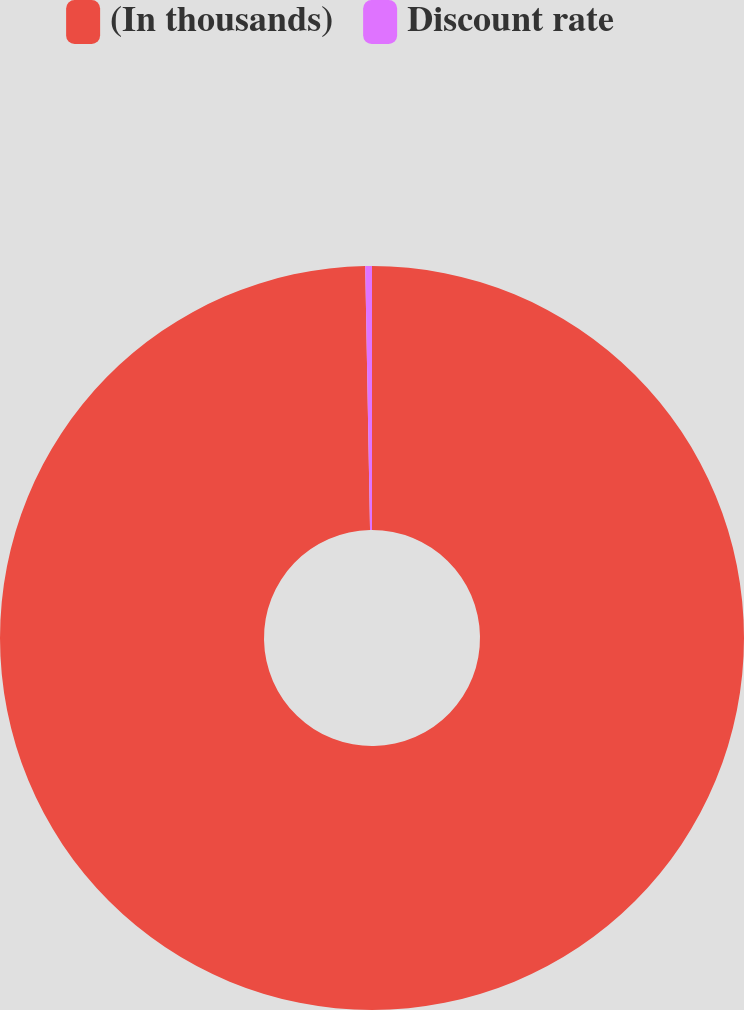Convert chart to OTSL. <chart><loc_0><loc_0><loc_500><loc_500><pie_chart><fcel>(In thousands)<fcel>Discount rate<nl><fcel>99.71%<fcel>0.29%<nl></chart> 